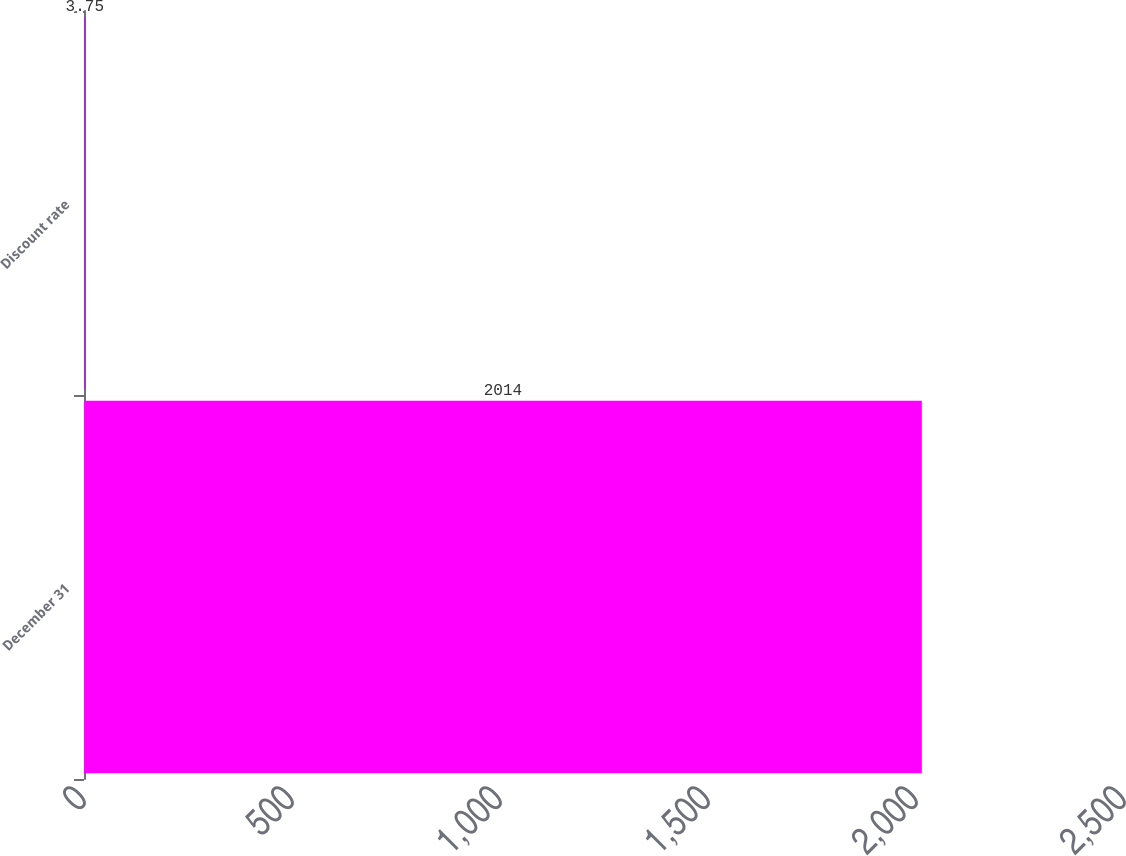Convert chart. <chart><loc_0><loc_0><loc_500><loc_500><bar_chart><fcel>December 31<fcel>Discount rate<nl><fcel>2014<fcel>3.75<nl></chart> 